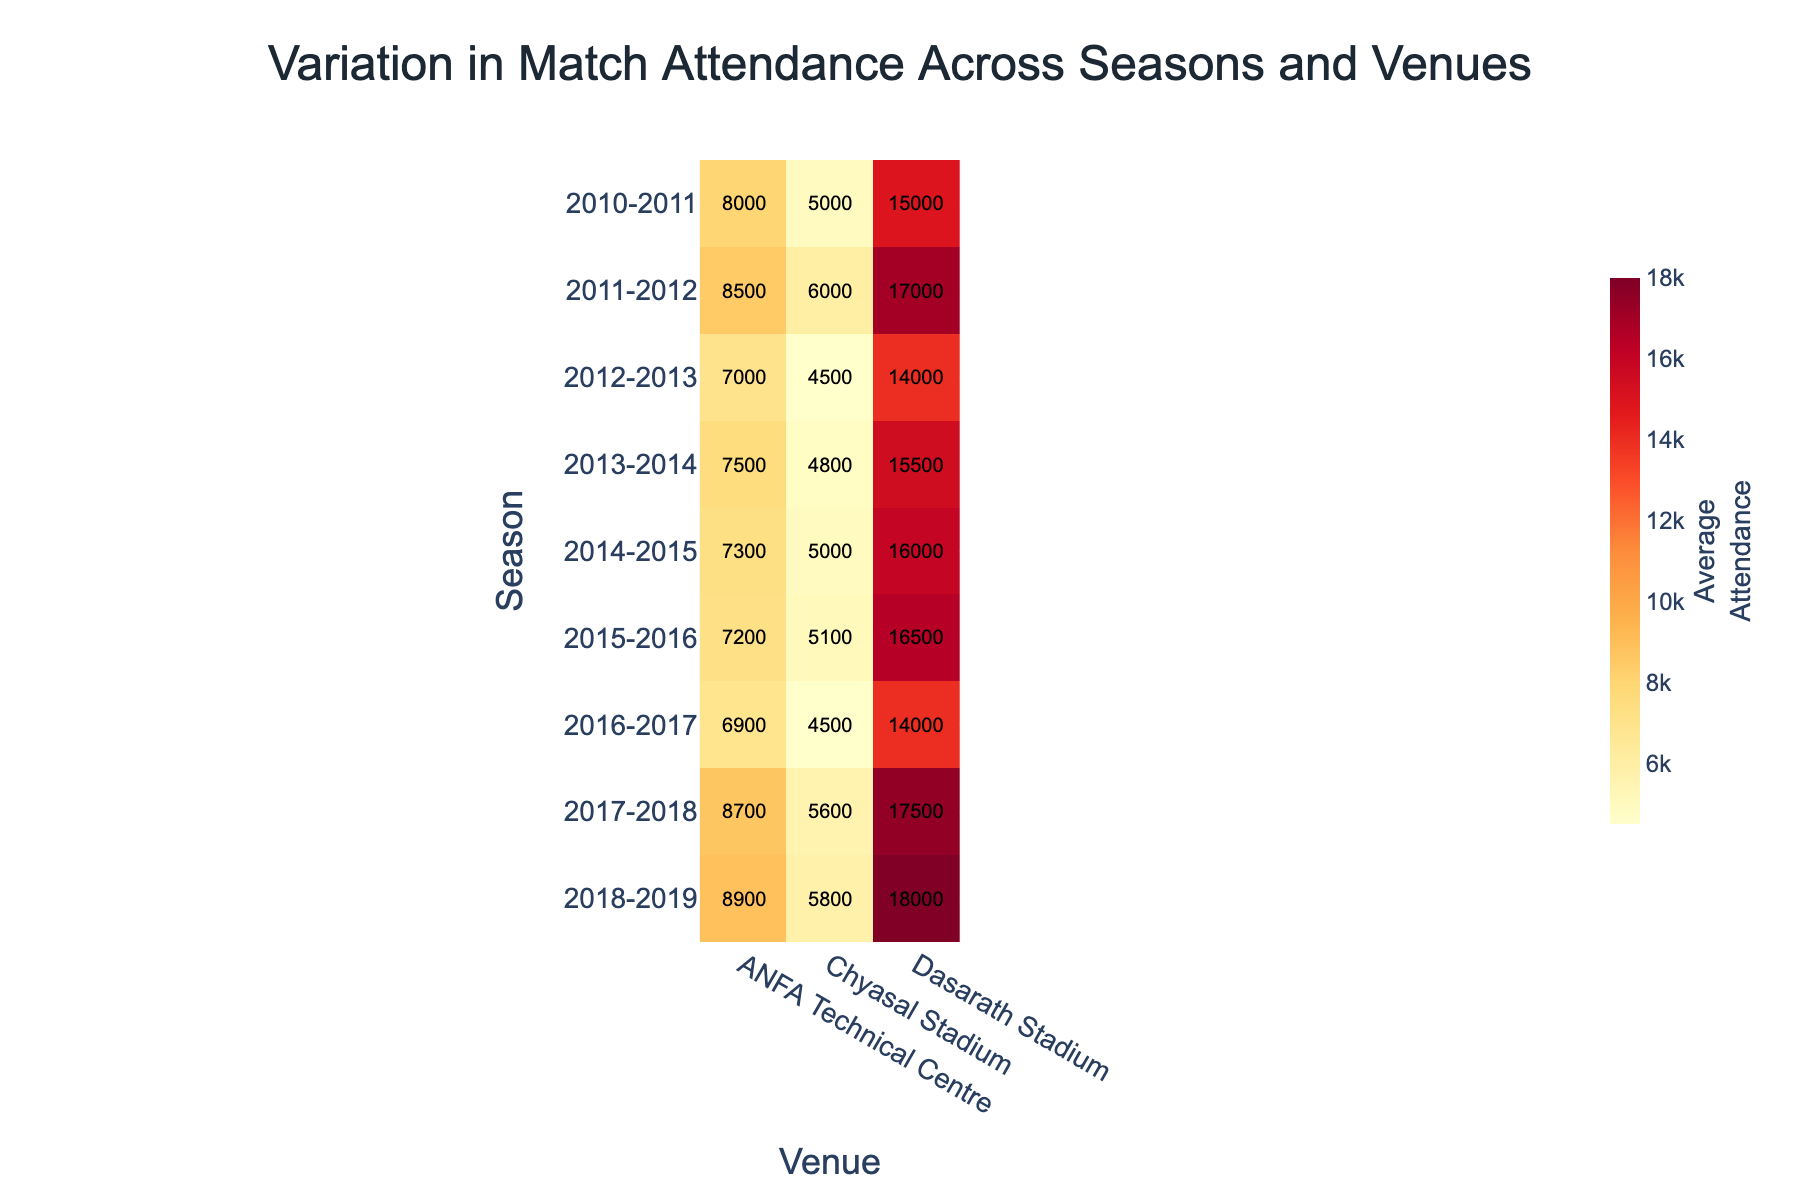What's the average attendance at Dasarath Stadium in the 2010-2011 season? Look for the cell in the heatmap for the 2010-2011 season under the column for Dasarath Stadium. The number there is the average attendance.
Answer: 15000 Which venue had the highest average attendance in the 2018-2019 season? Identify the cells for the 2018-2019 season and check the attendance values for each venue. The highest number represents the most popular venue.
Answer: Dasarath Stadium What's the difference in average attendance between ANFA Technical Centre in the 2012-2013 season and 2014-2015 season? Locate the attendance values for ANFA Technical Centre in both seasons and subtract the 2012-2013 value from the 2014-2015 value.
Answer: 300 How did the average attendance at Chyasal Stadium change from the 2010-2011 season to the 2018-2019 season? Find the attendance values for Chyasal Stadium in both seasons and note the difference by subtracting the 2010-2011 value from the 2018-2019 value.
Answer: +800 What is the trend in attendance at Dasarath Stadium across the seasons shown? Observe the values for Dasarath Stadium down the rows, noting increases, decreases, and overall patterns.
Answer: Increasing trend with fluctuations In which season did ANFA Technical Centre have its lowest average attendance? Identify the minimum value in the ANFA Technical Centre column and note the corresponding season.
Answer: 2016-2017 Compare the average attendance of Chyasal Stadium in the 2011-2012 and 2017-2018 seasons; which season had higher attendance? Look at the values for both seasons under Chyasal Stadium and compare them to find which one is higher.
Answer: 2017-2018 What was the overall trend in attendance for ANFA Technical Centre from the 2010-2011 season to the 2018-2019 season? Check the values from 2010-2011 to 2018-2019 for ANFA Technical Centre and observe whether they are increasing, decreasing, or fluctuating.
Answer: Slightly increasing trend Which venue consistently had the highest average attendance across most seasons? Compare the attendance values for all seasons and venues, identifying the venue with the highest or consistently high values most often.
Answer: Dasarath Stadium 